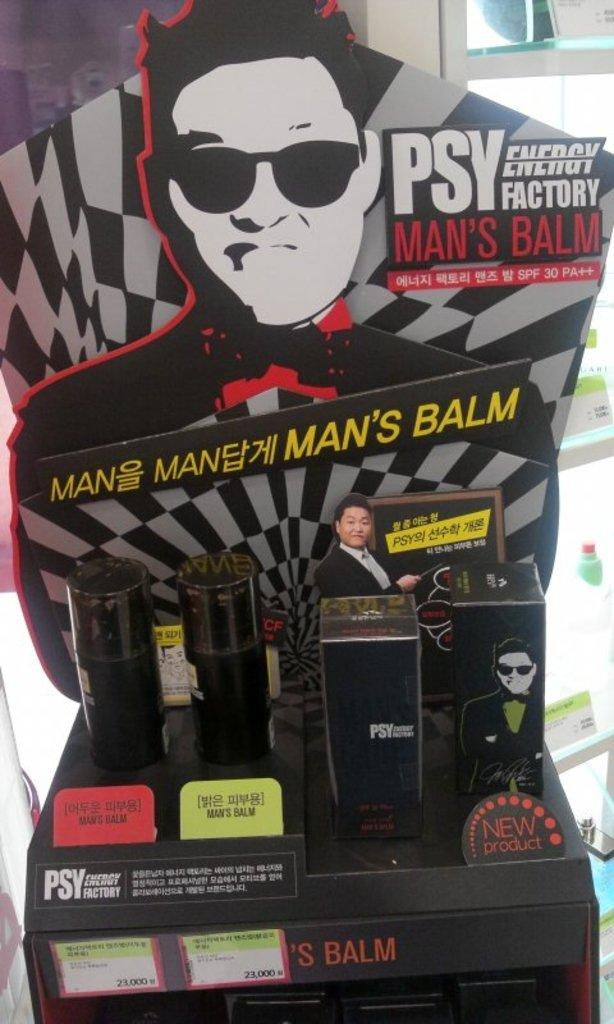<image>
Present a compact description of the photo's key features. Psy Energy Factory Man's Balm package with 4 packages and multiple photos of Psy. 